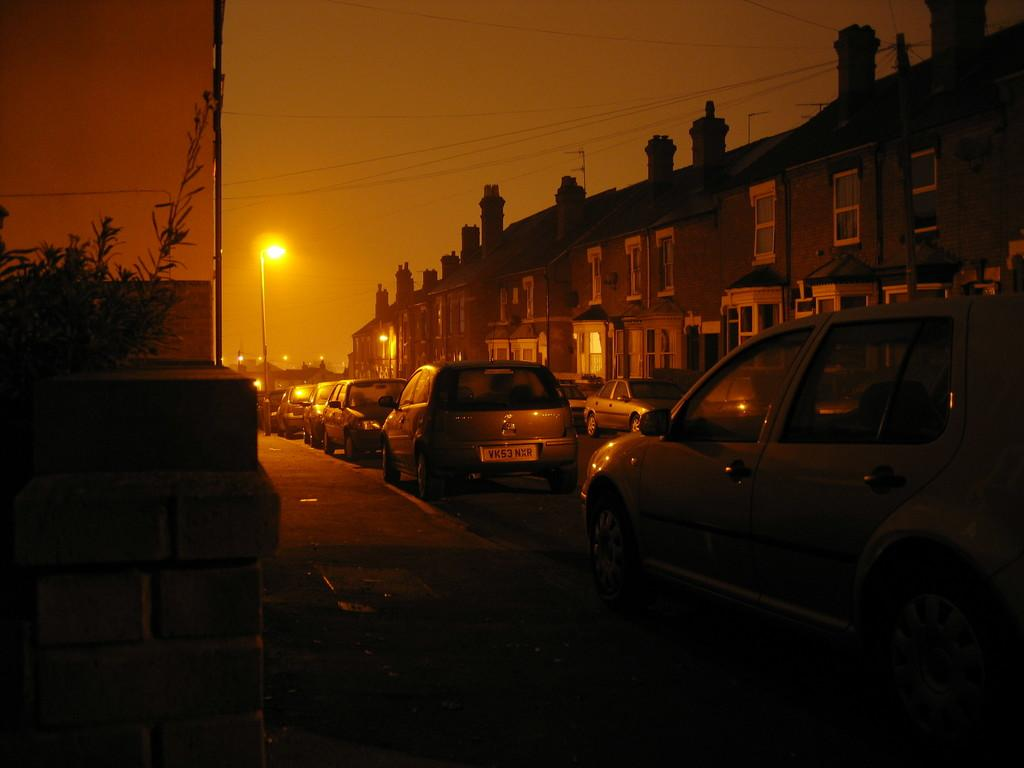What is present on the road in the image? There are vehicles on the road in the image. What else can be seen beside the vehicles? There is a plant beside the vehicles. What type of structures are visible in the image? There are buildings visible in the image. What can be seen in the background of the image? There are poles and lights in the background of the image. Can you show me the map that the vehicles are using to navigate in the image? There is no map present in the image; the vehicles are simply driving on the road. How does the air affect the movement of the vehicles in the image? The image does not provide information about the air or its effect on the vehicles; it only shows the vehicles on the road. 